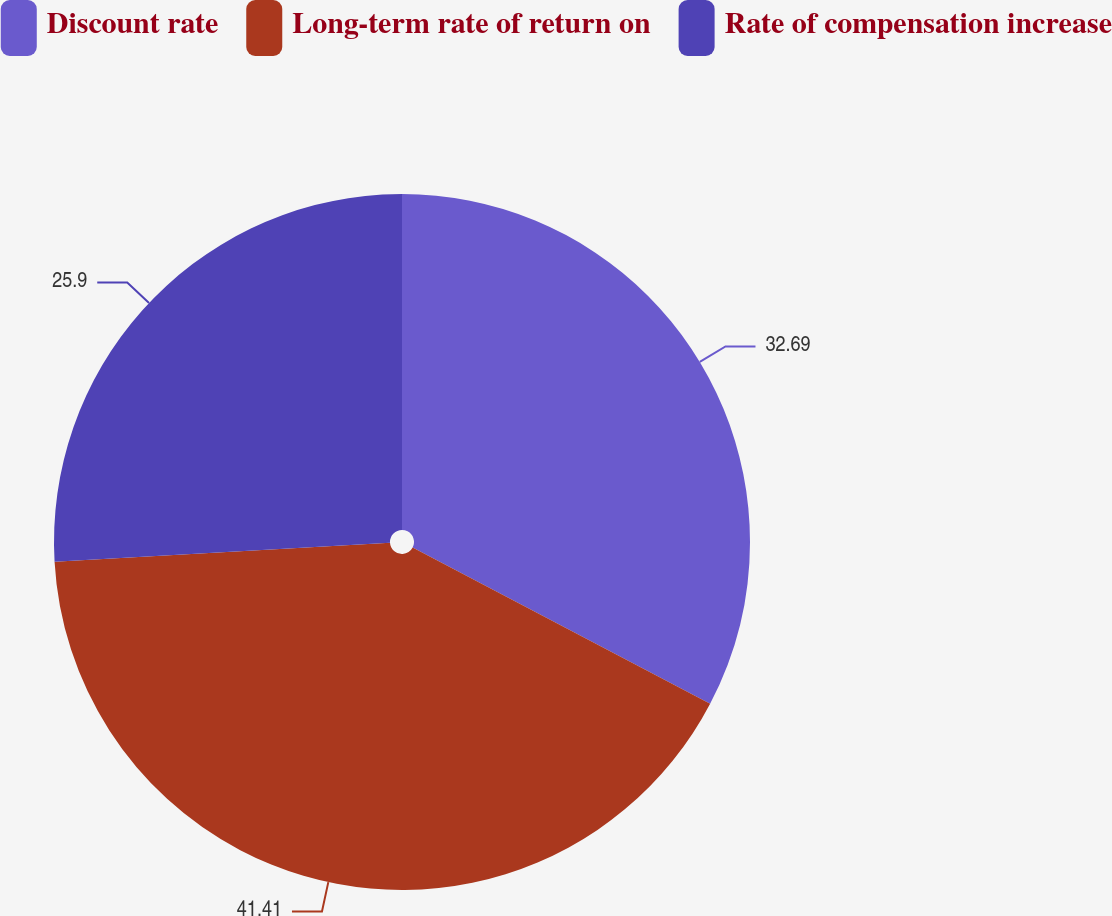Convert chart to OTSL. <chart><loc_0><loc_0><loc_500><loc_500><pie_chart><fcel>Discount rate<fcel>Long-term rate of return on<fcel>Rate of compensation increase<nl><fcel>32.69%<fcel>41.4%<fcel>25.9%<nl></chart> 